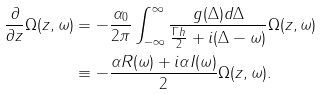Convert formula to latex. <formula><loc_0><loc_0><loc_500><loc_500>\frac { \partial } { \partial z } \Omega ( z , \omega ) & = - \frac { \alpha _ { 0 } } { 2 \pi } \int _ { - \infty } ^ { \infty } \frac { g ( \Delta ) d \Delta } { \frac { \Gamma h } { 2 } + i ( \Delta - \omega ) } \Omega ( z , \omega ) \\ & \equiv - \frac { \alpha R ( \omega ) + i \alpha I ( \omega ) } { 2 } \Omega ( z , \omega ) .</formula> 